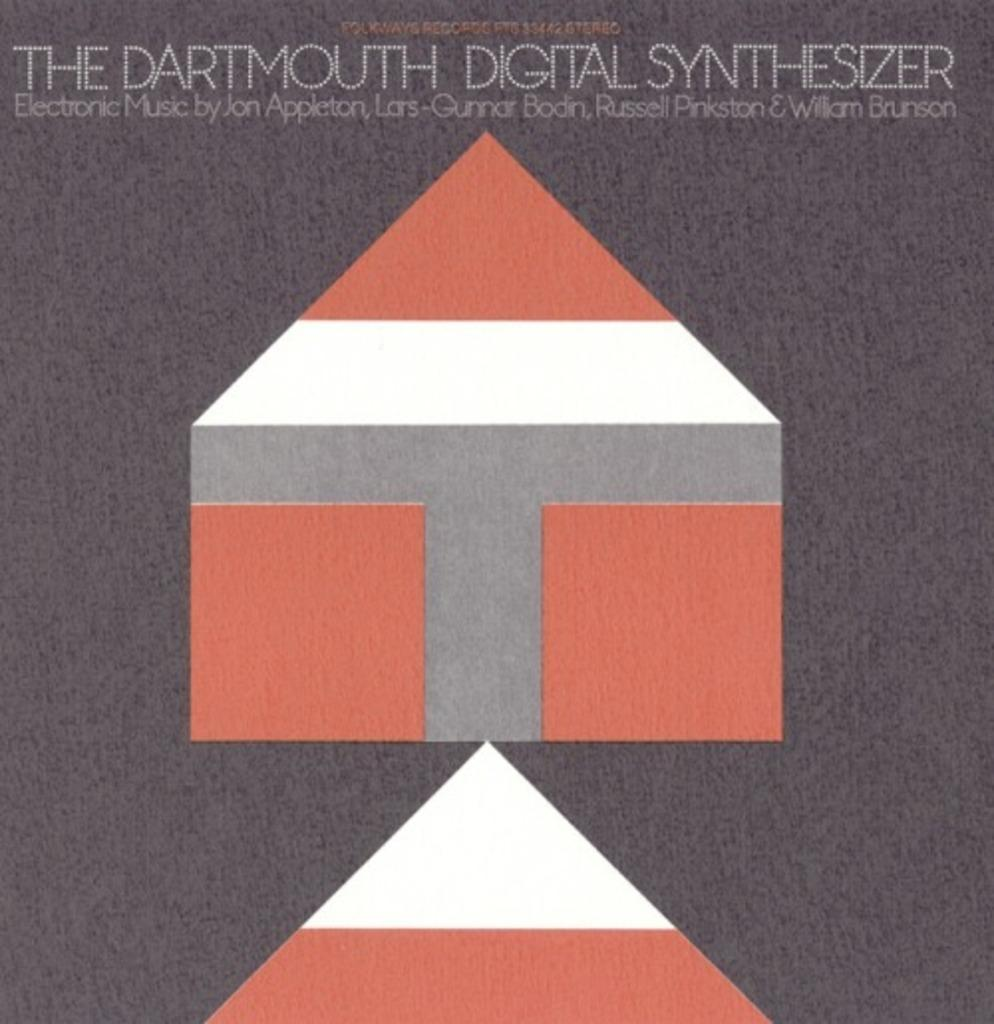<image>
Render a clear and concise summary of the photo. Object shaped like a house under words that say "The Dartmouth Digital Synthesizer". 